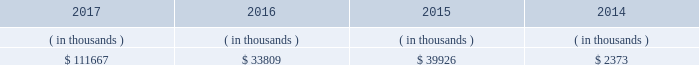System energy may refinance , redeem , or otherwise retire debt prior to maturity , to the extent market conditions and interest and dividend rates are favorable .
All debt and common stock issuances by system energy require prior regulatory approval . a0 a0debt issuances are also subject to issuance tests set forth in its bond indentures and other agreements . a0 a0system energy has sufficient capacity under these tests to meet its foreseeable capital needs .
System energy 2019s receivables from the money pool were as follows as of december 31 for each of the following years. .
See note 4 to the financial statements for a description of the money pool .
The system energy nuclear fuel company variable interest entity has a credit facility in the amount of $ 120 million scheduled to expire in may 2019 .
As of december 31 , 2017 , $ 17.8 million in letters of credit to support a like amount of commercial paper issued and $ 50 million in loans were outstanding under the system energy nuclear fuel company variable interest entity credit facility .
See note 4 to the financial statements for additional discussion of the variable interest entity credit facility .
System energy obtained authorizations from the ferc through october 2019 for the following : 2022 short-term borrowings not to exceed an aggregate amount of $ 200 million at any time outstanding ; 2022 long-term borrowings and security issuances ; and 2022 long-term borrowings by its nuclear fuel company variable interest entity .
See note 4 to the financial statements for further discussion of system energy 2019s short-term borrowing limits .
System energy resources , inc .
Management 2019s financial discussion and analysis federal regulation see the 201crate , cost-recovery , and other regulation 2013 federal regulation 201d section of entergy corporation and subsidiaries management 2019s financial discussion and analysis and note 2 to the financial statements for a discussion of federal regulation .
Complaint against system energy in january 2017 the apsc and mpsc filed a complaint with the ferc against system energy .
The complaint seeks a reduction in the return on equity component of the unit power sales agreement pursuant to which system energy sells its grand gulf capacity and energy to entergy arkansas , entergy louisiana , entergy mississippi , and entergy new orleans .
Entergy arkansas also sells some of its grand gulf capacity and energy to entergy louisiana , entergy mississippi , and entergy new orleans under separate agreements .
The current return on equity under the unit power sales agreement is 10.94% ( 10.94 % ) .
The complaint alleges that the return on equity is unjust and unreasonable because current capital market and other considerations indicate that it is excessive .
The complaint requests the ferc to institute proceedings to investigate the return on equity and establish a lower return on equity , and also requests that the ferc establish january 23 , 2017 as a refund effective date .
The complaint includes return on equity analysis that purports to establish that the range of reasonable return on equity for system energy is between 8.37% ( 8.37 % ) and 8.67% ( 8.67 % ) .
System energy answered the complaint in february 2017 and disputes that a return on equity of 8.37% ( 8.37 % ) to 8.67% ( 8.67 % ) is just and reasonable .
The lpsc and the city council intervened in the proceeding expressing support for the complaint .
System energy is recording a provision against revenue for the potential outcome of this proceeding .
In september 2017 the ferc established a refund effective date of january 23 , 2017 , consolidated the return on equity complaint with the proceeding described in unit power sales agreement below , and directed the parties to engage in settlement .
As of december 31 , 2017 what was the percent of the system energy credit facility utilization? 
Computations: ((17.8 + 50) / 120)
Answer: 0.565. 